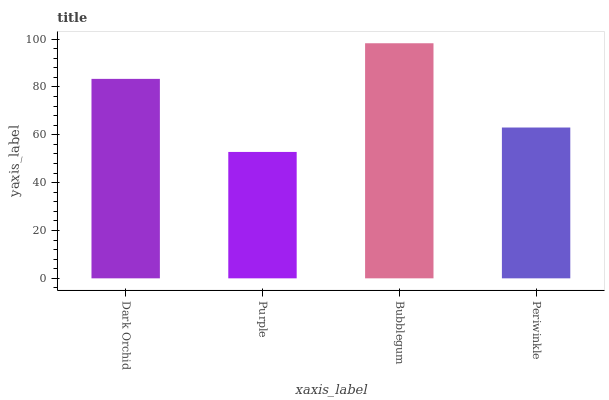Is Purple the minimum?
Answer yes or no. Yes. Is Bubblegum the maximum?
Answer yes or no. Yes. Is Bubblegum the minimum?
Answer yes or no. No. Is Purple the maximum?
Answer yes or no. No. Is Bubblegum greater than Purple?
Answer yes or no. Yes. Is Purple less than Bubblegum?
Answer yes or no. Yes. Is Purple greater than Bubblegum?
Answer yes or no. No. Is Bubblegum less than Purple?
Answer yes or no. No. Is Dark Orchid the high median?
Answer yes or no. Yes. Is Periwinkle the low median?
Answer yes or no. Yes. Is Bubblegum the high median?
Answer yes or no. No. Is Bubblegum the low median?
Answer yes or no. No. 